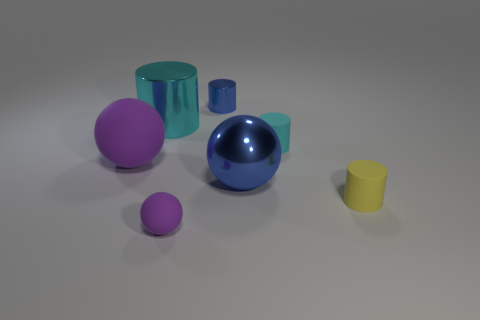Add 1 large red metallic cubes. How many objects exist? 8 Subtract all cylinders. How many objects are left? 3 Add 4 yellow matte things. How many yellow matte things are left? 5 Add 2 blue things. How many blue things exist? 4 Subtract 1 blue cylinders. How many objects are left? 6 Subtract all purple matte spheres. Subtract all rubber cylinders. How many objects are left? 3 